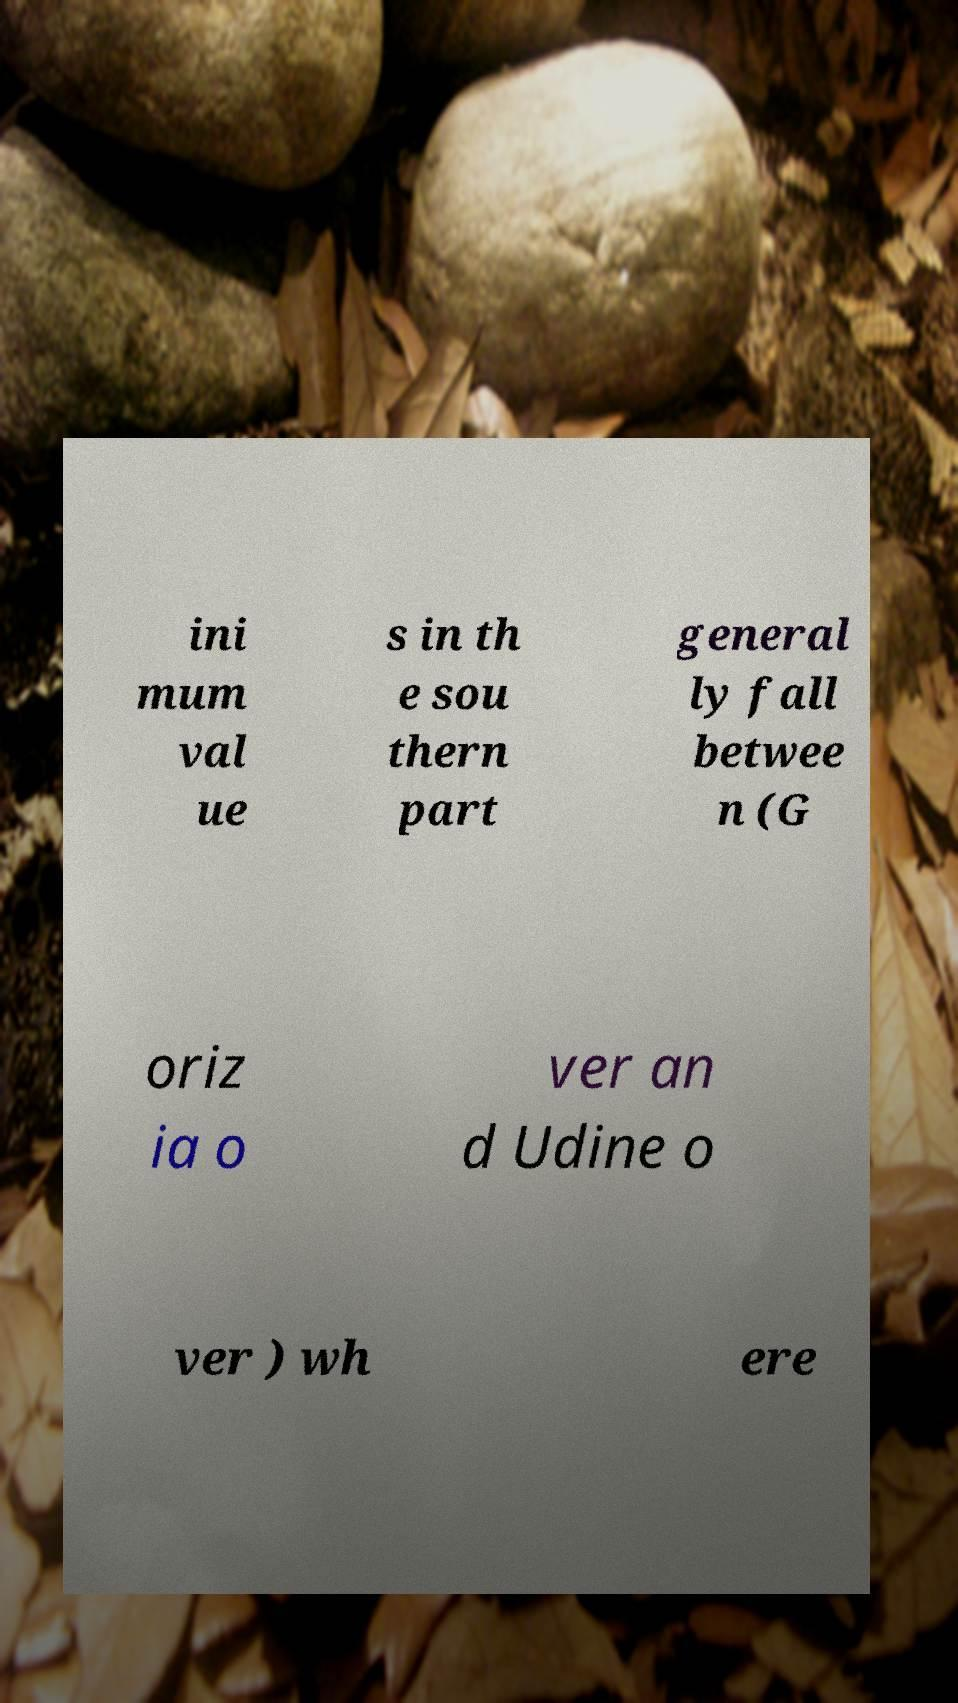Please read and relay the text visible in this image. What does it say? ini mum val ue s in th e sou thern part general ly fall betwee n (G oriz ia o ver an d Udine o ver ) wh ere 